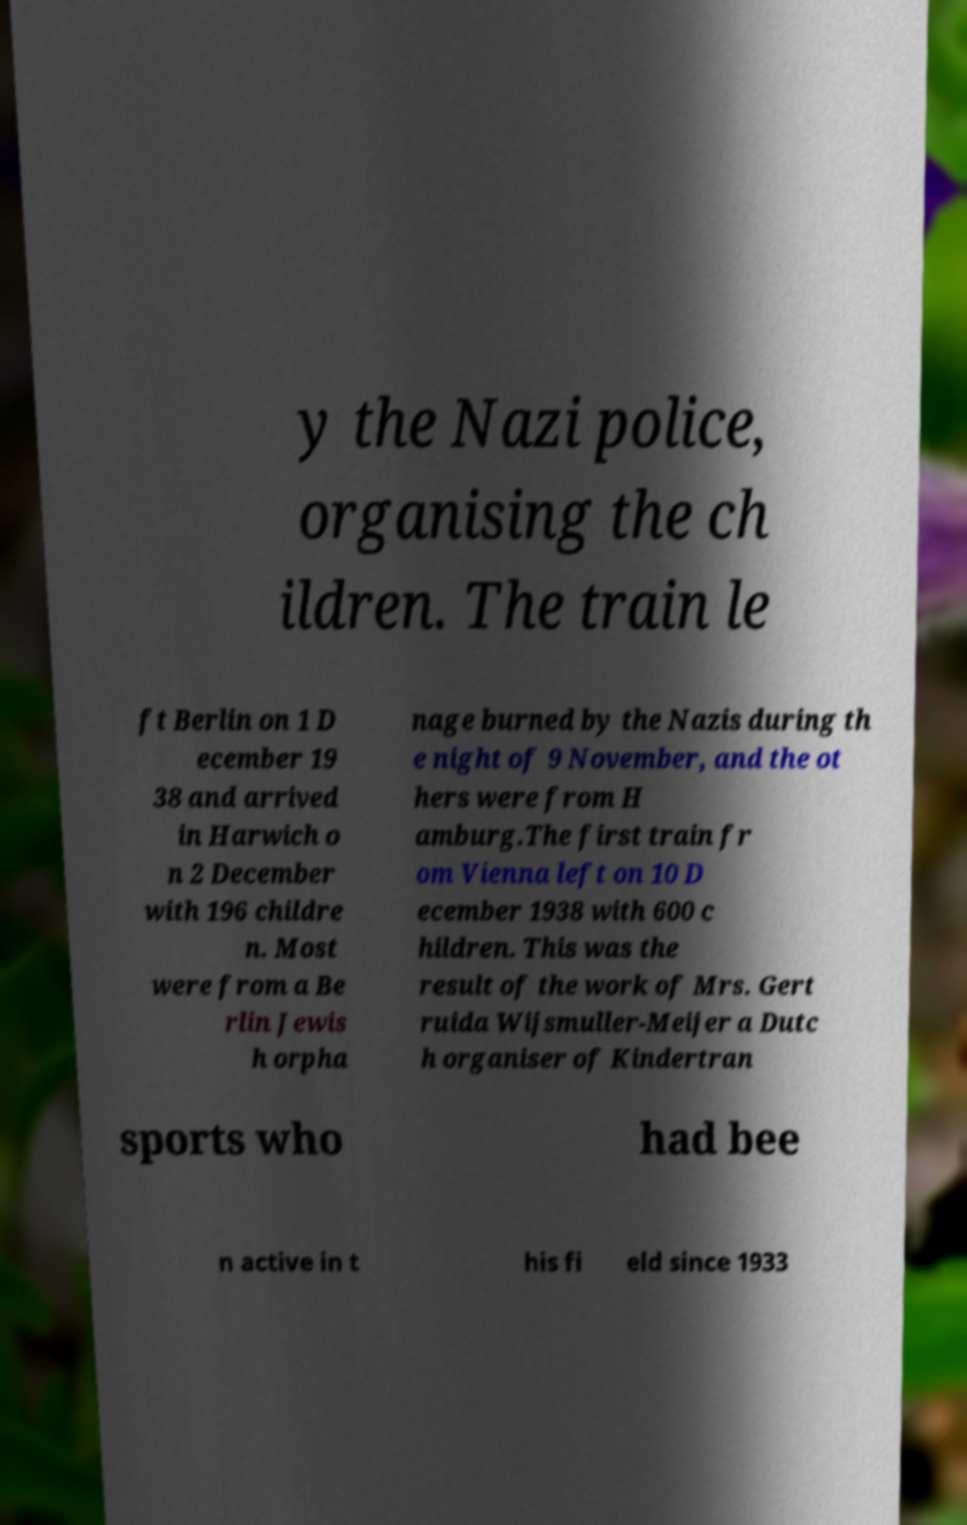I need the written content from this picture converted into text. Can you do that? y the Nazi police, organising the ch ildren. The train le ft Berlin on 1 D ecember 19 38 and arrived in Harwich o n 2 December with 196 childre n. Most were from a Be rlin Jewis h orpha nage burned by the Nazis during th e night of 9 November, and the ot hers were from H amburg.The first train fr om Vienna left on 10 D ecember 1938 with 600 c hildren. This was the result of the work of Mrs. Gert ruida Wijsmuller-Meijer a Dutc h organiser of Kindertran sports who had bee n active in t his fi eld since 1933 